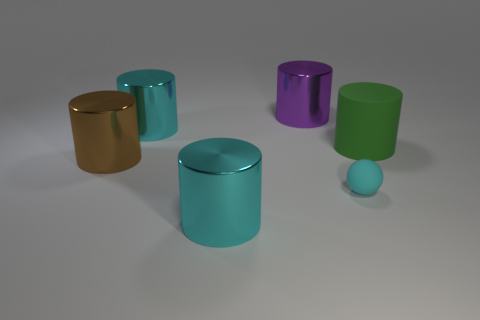What number of small objects are either brown matte cylinders or cyan metal things?
Your response must be concise. 0. Is the cyan cylinder in front of the green object made of the same material as the big green object?
Ensure brevity in your answer.  No. What is the shape of the large cyan metal thing behind the large matte object that is in front of the cyan metal cylinder behind the cyan matte object?
Give a very brief answer. Cylinder. How many brown things are either large things or matte cylinders?
Make the answer very short. 1. Are there the same number of big purple shiny things that are to the right of the purple metal cylinder and large green matte cylinders on the left side of the big brown thing?
Give a very brief answer. Yes. There is a big cyan thing behind the matte cylinder; does it have the same shape as the brown metal thing on the left side of the big rubber thing?
Provide a short and direct response. Yes. Are there any other things that have the same shape as the tiny cyan matte thing?
Your response must be concise. No. There is a large brown thing that is the same material as the large purple cylinder; what is its shape?
Provide a short and direct response. Cylinder. Is the number of big brown shiny things that are right of the tiny cyan matte ball the same as the number of cyan shiny objects?
Give a very brief answer. No. Does the cyan object that is to the right of the large purple metal object have the same material as the cyan cylinder behind the brown metal cylinder?
Your response must be concise. No. 